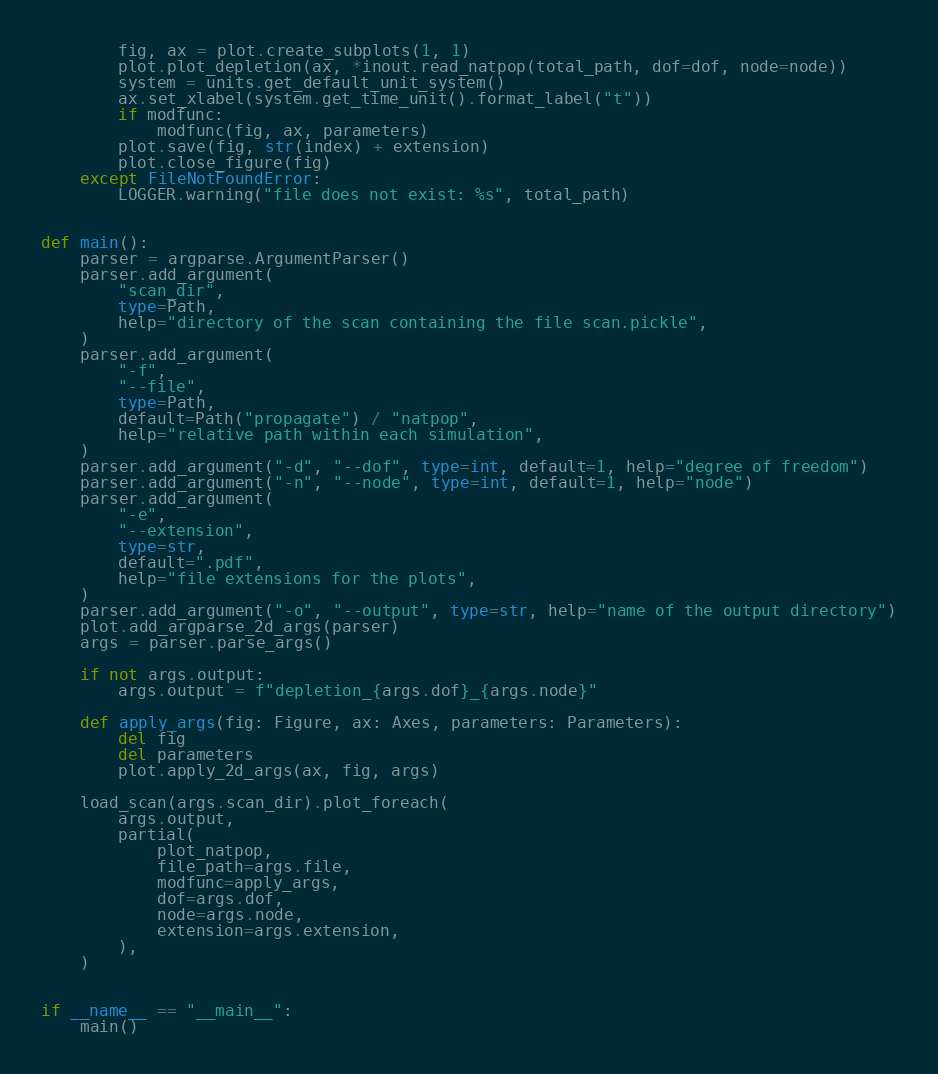Convert code to text. <code><loc_0><loc_0><loc_500><loc_500><_Python_>        fig, ax = plot.create_subplots(1, 1)
        plot.plot_depletion(ax, *inout.read_natpop(total_path, dof=dof, node=node))
        system = units.get_default_unit_system()
        ax.set_xlabel(system.get_time_unit().format_label("t"))
        if modfunc:
            modfunc(fig, ax, parameters)
        plot.save(fig, str(index) + extension)
        plot.close_figure(fig)
    except FileNotFoundError:
        LOGGER.warning("file does not exist: %s", total_path)


def main():
    parser = argparse.ArgumentParser()
    parser.add_argument(
        "scan_dir",
        type=Path,
        help="directory of the scan containing the file scan.pickle",
    )
    parser.add_argument(
        "-f",
        "--file",
        type=Path,
        default=Path("propagate") / "natpop",
        help="relative path within each simulation",
    )
    parser.add_argument("-d", "--dof", type=int, default=1, help="degree of freedom")
    parser.add_argument("-n", "--node", type=int, default=1, help="node")
    parser.add_argument(
        "-e",
        "--extension",
        type=str,
        default=".pdf",
        help="file extensions for the plots",
    )
    parser.add_argument("-o", "--output", type=str, help="name of the output directory")
    plot.add_argparse_2d_args(parser)
    args = parser.parse_args()

    if not args.output:
        args.output = f"depletion_{args.dof}_{args.node}"

    def apply_args(fig: Figure, ax: Axes, parameters: Parameters):
        del fig
        del parameters
        plot.apply_2d_args(ax, fig, args)

    load_scan(args.scan_dir).plot_foreach(
        args.output,
        partial(
            plot_natpop,
            file_path=args.file,
            modfunc=apply_args,
            dof=args.dof,
            node=args.node,
            extension=args.extension,
        ),
    )


if __name__ == "__main__":
    main()
</code> 